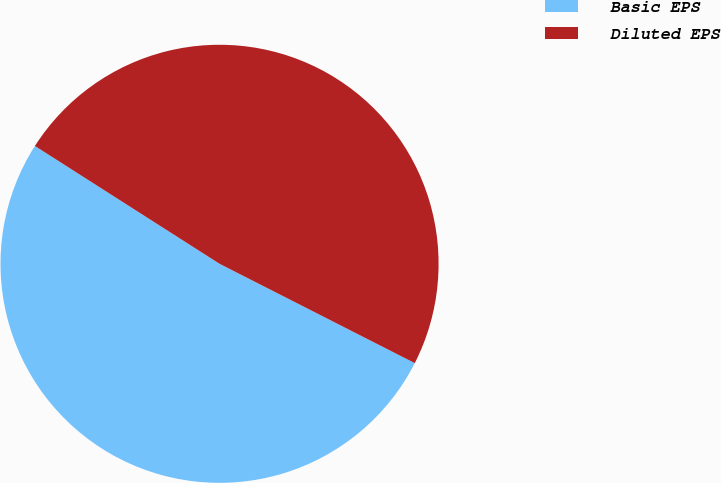Convert chart to OTSL. <chart><loc_0><loc_0><loc_500><loc_500><pie_chart><fcel>Basic EPS<fcel>Diluted EPS<nl><fcel>51.55%<fcel>48.45%<nl></chart> 